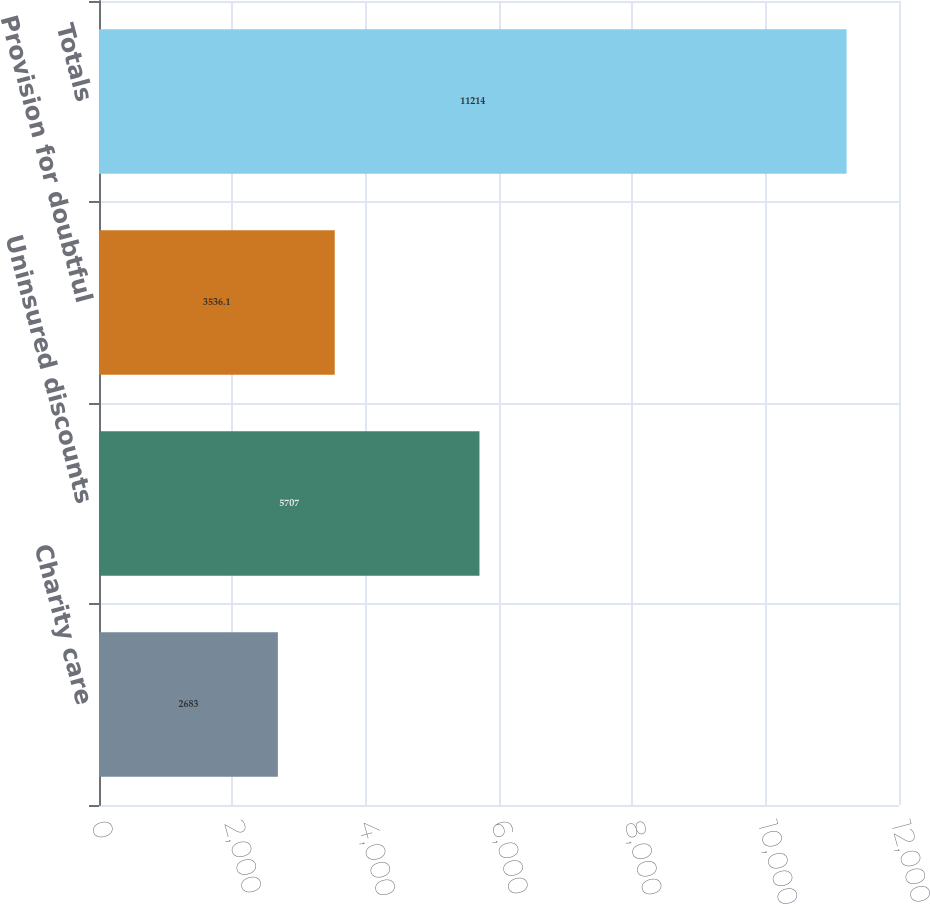<chart> <loc_0><loc_0><loc_500><loc_500><bar_chart><fcel>Charity care<fcel>Uninsured discounts<fcel>Provision for doubtful<fcel>Totals<nl><fcel>2683<fcel>5707<fcel>3536.1<fcel>11214<nl></chart> 